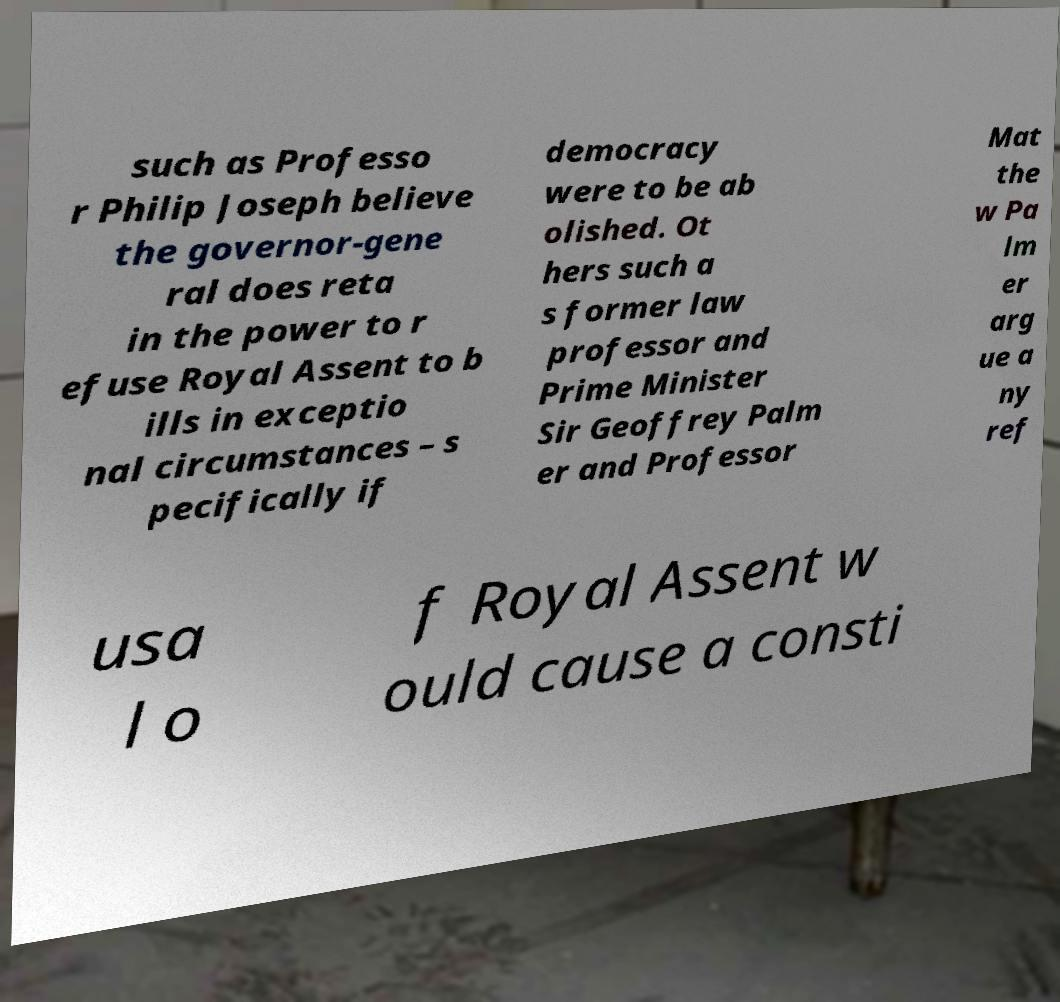Can you read and provide the text displayed in the image?This photo seems to have some interesting text. Can you extract and type it out for me? such as Professo r Philip Joseph believe the governor-gene ral does reta in the power to r efuse Royal Assent to b ills in exceptio nal circumstances – s pecifically if democracy were to be ab olished. Ot hers such a s former law professor and Prime Minister Sir Geoffrey Palm er and Professor Mat the w Pa lm er arg ue a ny ref usa l o f Royal Assent w ould cause a consti 